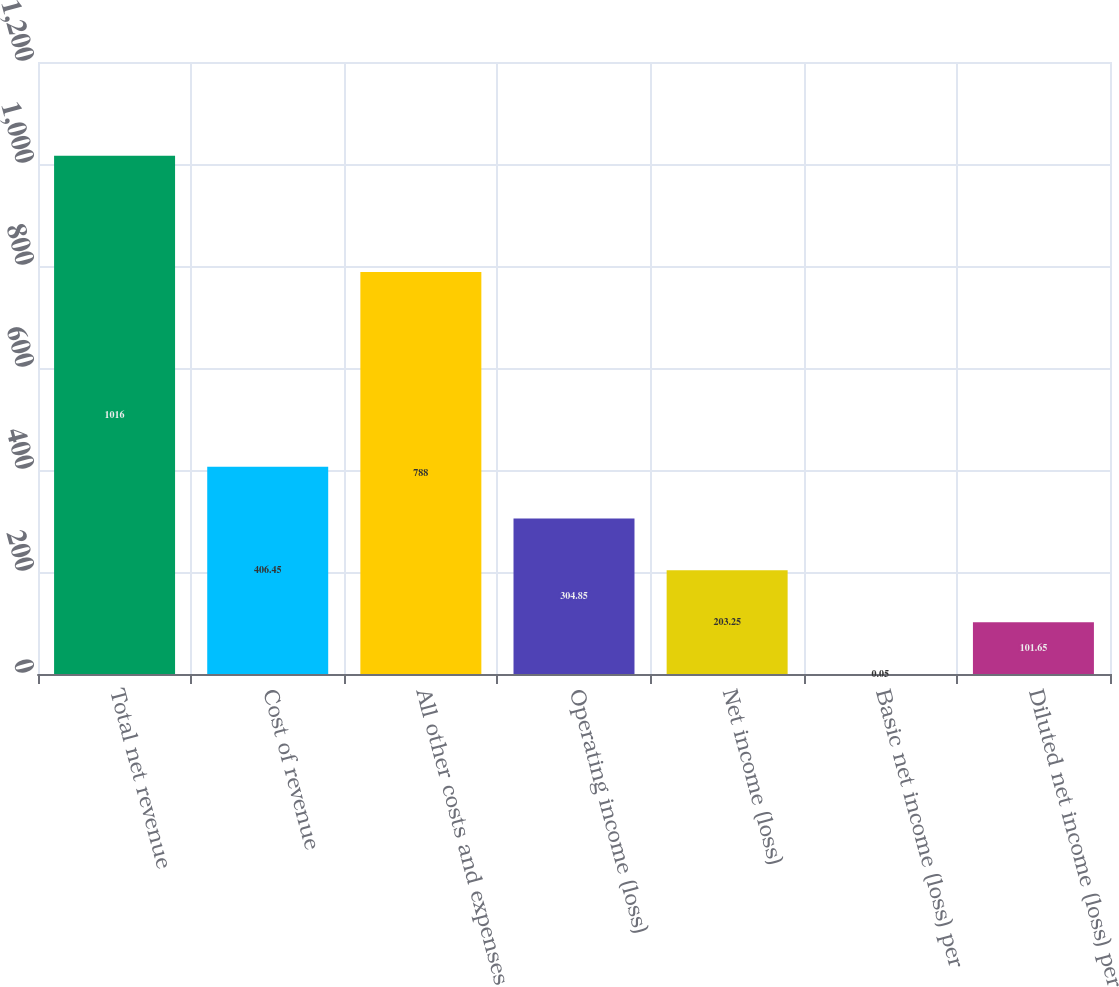Convert chart. <chart><loc_0><loc_0><loc_500><loc_500><bar_chart><fcel>Total net revenue<fcel>Cost of revenue<fcel>All other costs and expenses<fcel>Operating income (loss)<fcel>Net income (loss)<fcel>Basic net income (loss) per<fcel>Diluted net income (loss) per<nl><fcel>1016<fcel>406.45<fcel>788<fcel>304.85<fcel>203.25<fcel>0.05<fcel>101.65<nl></chart> 